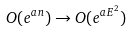<formula> <loc_0><loc_0><loc_500><loc_500>O ( e ^ { a n } ) \rightarrow O ( e ^ { a E ^ { 2 } } )</formula> 